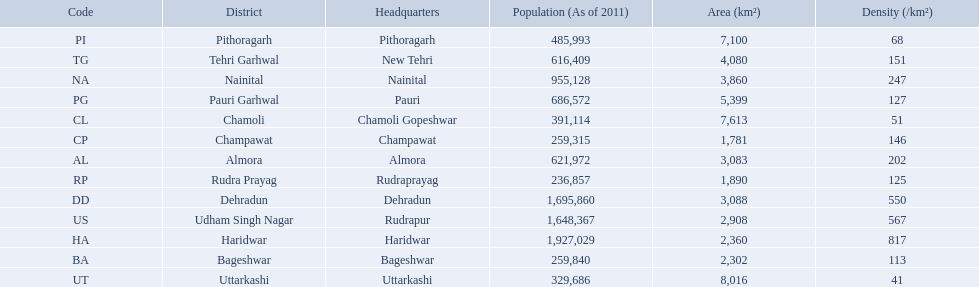What are the names of all the districts? Almora, Bageshwar, Chamoli, Champawat, Dehradun, Haridwar, Nainital, Pauri Garhwal, Pithoragarh, Rudra Prayag, Tehri Garhwal, Udham Singh Nagar, Uttarkashi. What range of densities do these districts encompass? 202, 113, 51, 146, 550, 817, 247, 127, 68, 125, 151, 567, 41. Which district has a density of 51? Chamoli. 